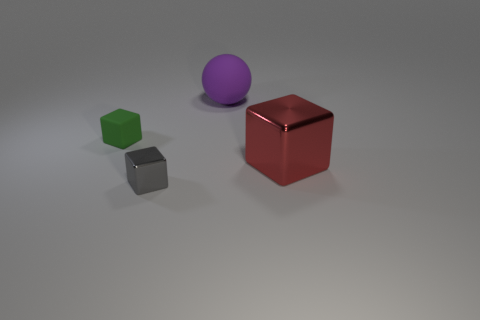Subtract all blue cubes. Subtract all brown spheres. How many cubes are left? 3 Add 3 red metallic objects. How many objects exist? 7 Subtract all cubes. How many objects are left? 1 Add 3 large shiny blocks. How many large shiny blocks are left? 4 Add 3 green blocks. How many green blocks exist? 4 Subtract 0 red balls. How many objects are left? 4 Subtract all big balls. Subtract all small cyan metal cylinders. How many objects are left? 3 